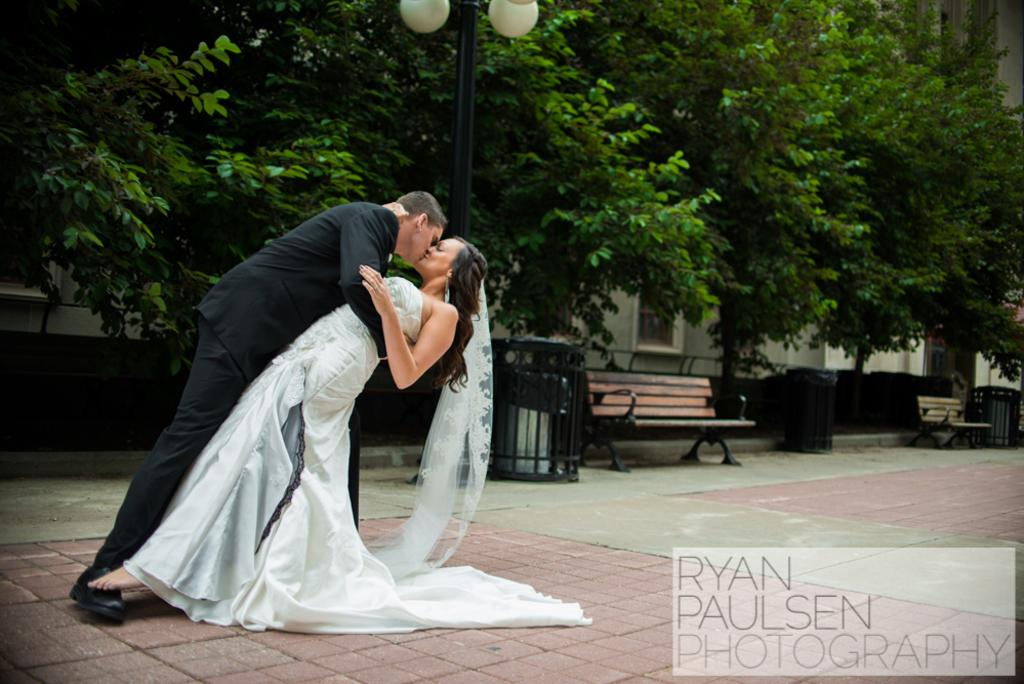Who are the main subjects in the image? There is a bride and a bridegroom in the image. What are the bride and bridegroom doing in the image? The bride and bridegroom are kissing each other in the image. What can be seen in the background of the image? There are benches, bins, and trees in the background of the image. What type of ray is visible in the image? There is no ray present in the image. Can you tell me how many times the bride and bridegroom have copied their vows in the image? There is no indication in the image that the bride and bridegroom are copying their vows or any other action. 